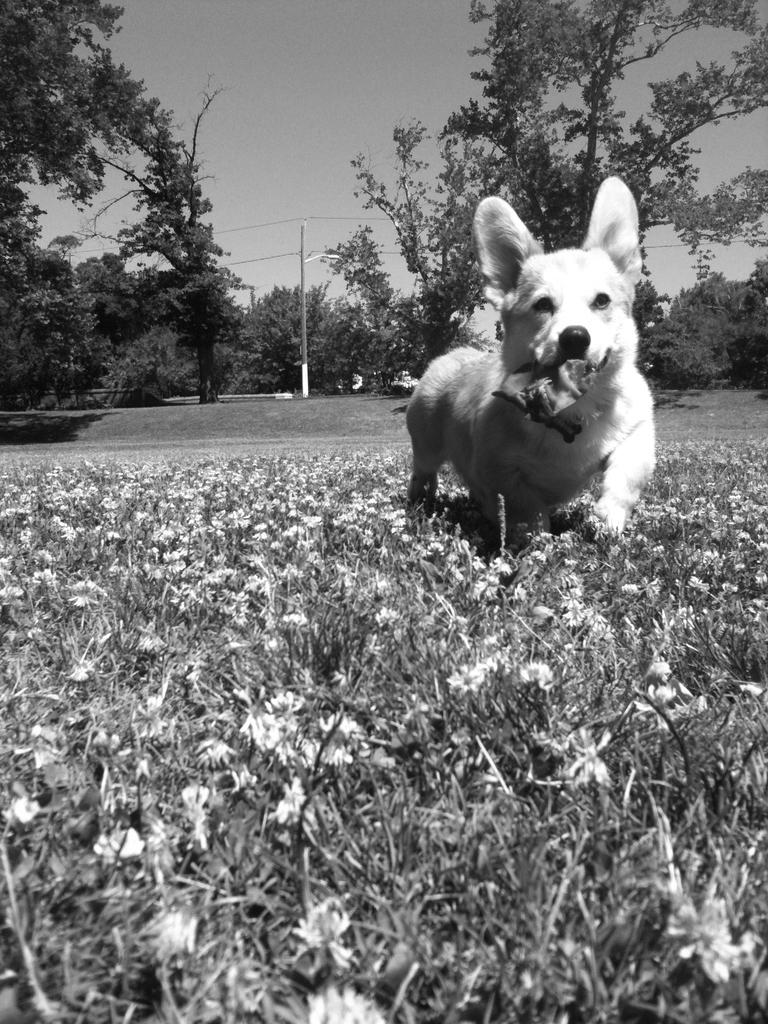What type of animal is present in the image? There is a dog in the image. What other living organisms can be seen in the image? There are plants in the image. Where are the plants located in relation to the image? The plants are located on the down side of the image. What can be seen in the background of the image? There are trees in the background of the image. What type of steel is used to construct the doghouse in the image? There is no doghouse present in the image, and therefore no steel can be observed. What type of berry can be seen growing on the plants in the image? There is no mention of berries in the image, and the plants are not described in detail. 